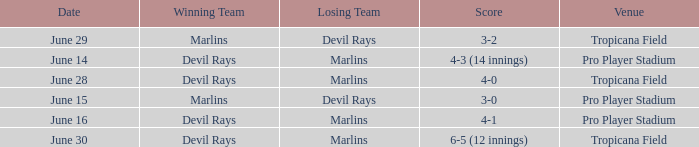What was the score of the game at pro player stadium on june 14? 4-3 (14 innings). 